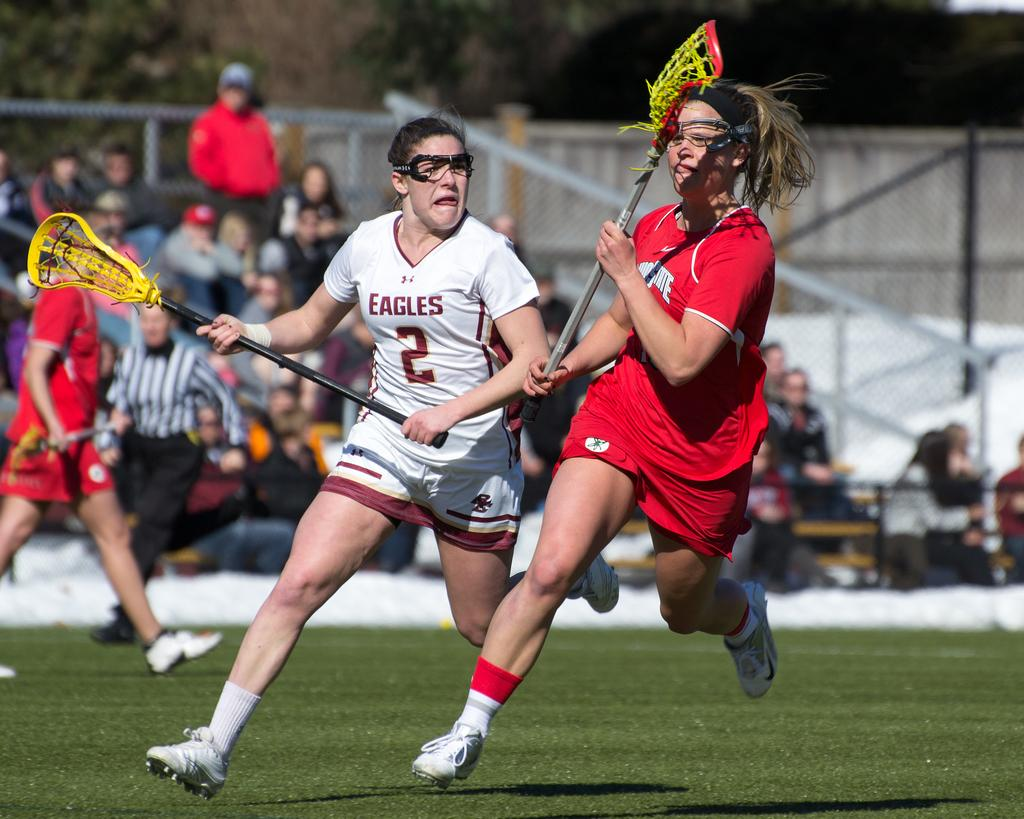How many women are in the foreground of the image? There are two women in the foreground of the image. What are the women doing in the image? The women are running in the image. What object are the women holding in the image? The women are holding a rod-like object in the image. What can be observed in the background of the image? There are many people sitting in the background of the image. What type of toothbrush can be seen in the hands of the women in the image? There is no toothbrush present in the image; the women are holding a rod-like object. 